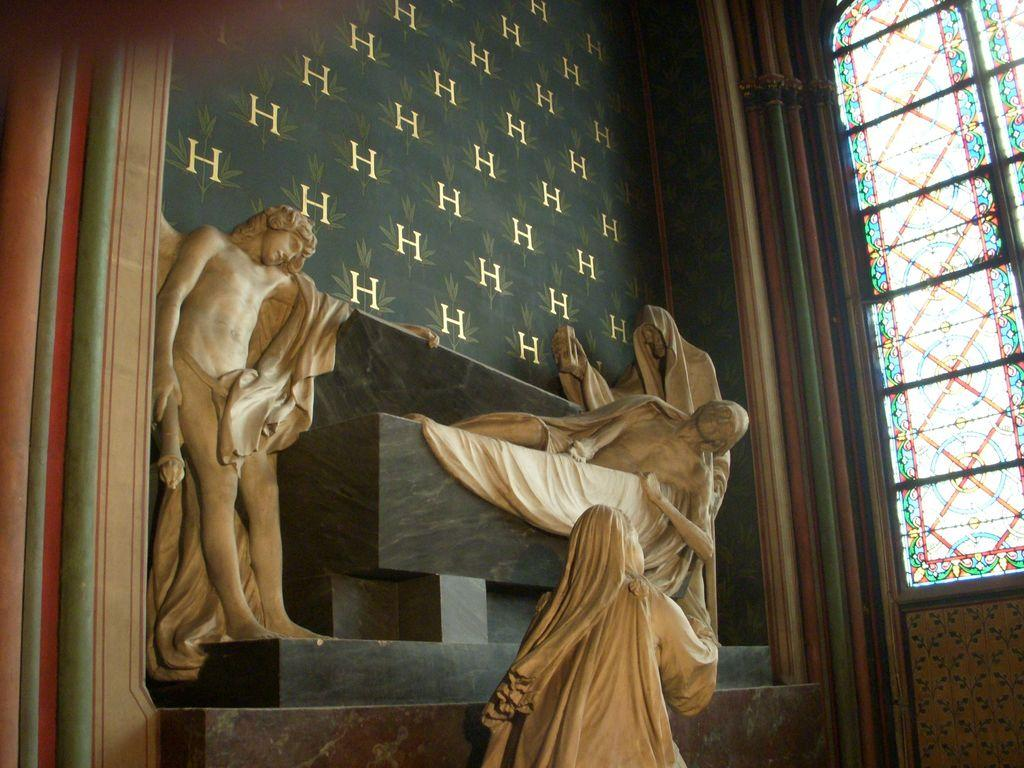What can be seen in the image that resembles human figures? There are statues of persons in the image. What is on the wall in the image? There is a wall with designs in the image. Where is the window located in the image? The window is on the right side of the image. How many chickens are sitting on the statues in the image? There are no chickens present in the image; it features statues of persons and a wall with designs. What type of harmony is being depicted in the image? The image does not depict any specific harmony; it simply shows statues, a wall with designs, and a window. 